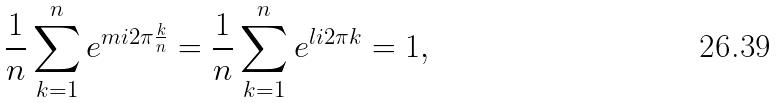<formula> <loc_0><loc_0><loc_500><loc_500>\frac { 1 } { n } \sum _ { k = 1 } ^ { n } e ^ { m i 2 \pi \frac { k } { n } } = \frac { 1 } { n } \sum _ { k = 1 } ^ { n } e ^ { l i 2 \pi k } = 1 ,</formula> 